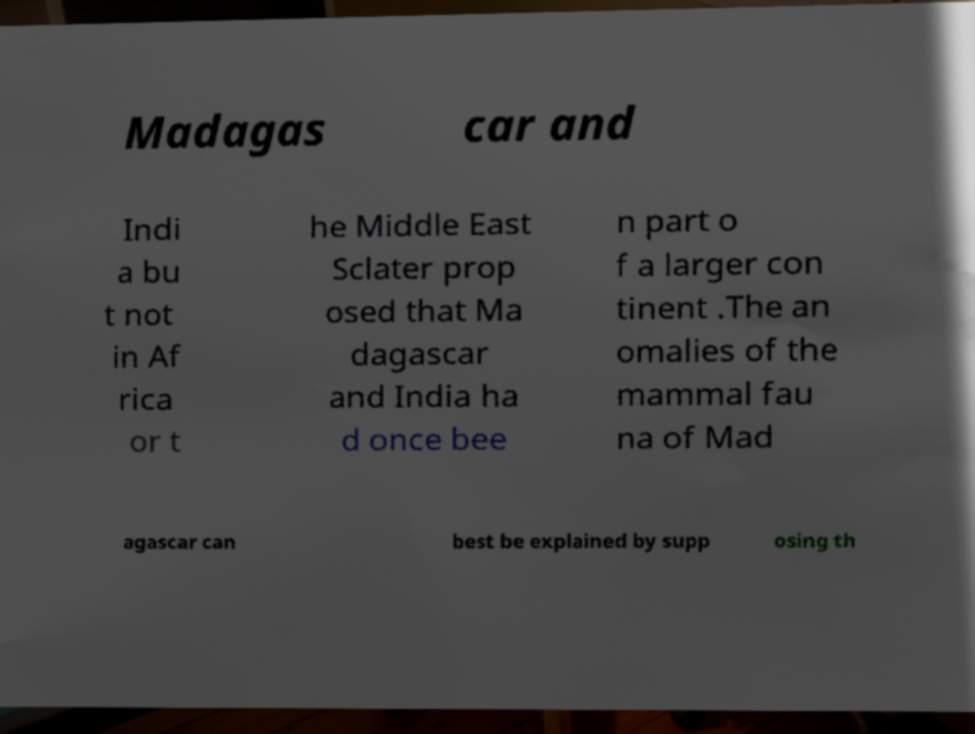Could you assist in decoding the text presented in this image and type it out clearly? Madagas car and Indi a bu t not in Af rica or t he Middle East Sclater prop osed that Ma dagascar and India ha d once bee n part o f a larger con tinent .The an omalies of the mammal fau na of Mad agascar can best be explained by supp osing th 